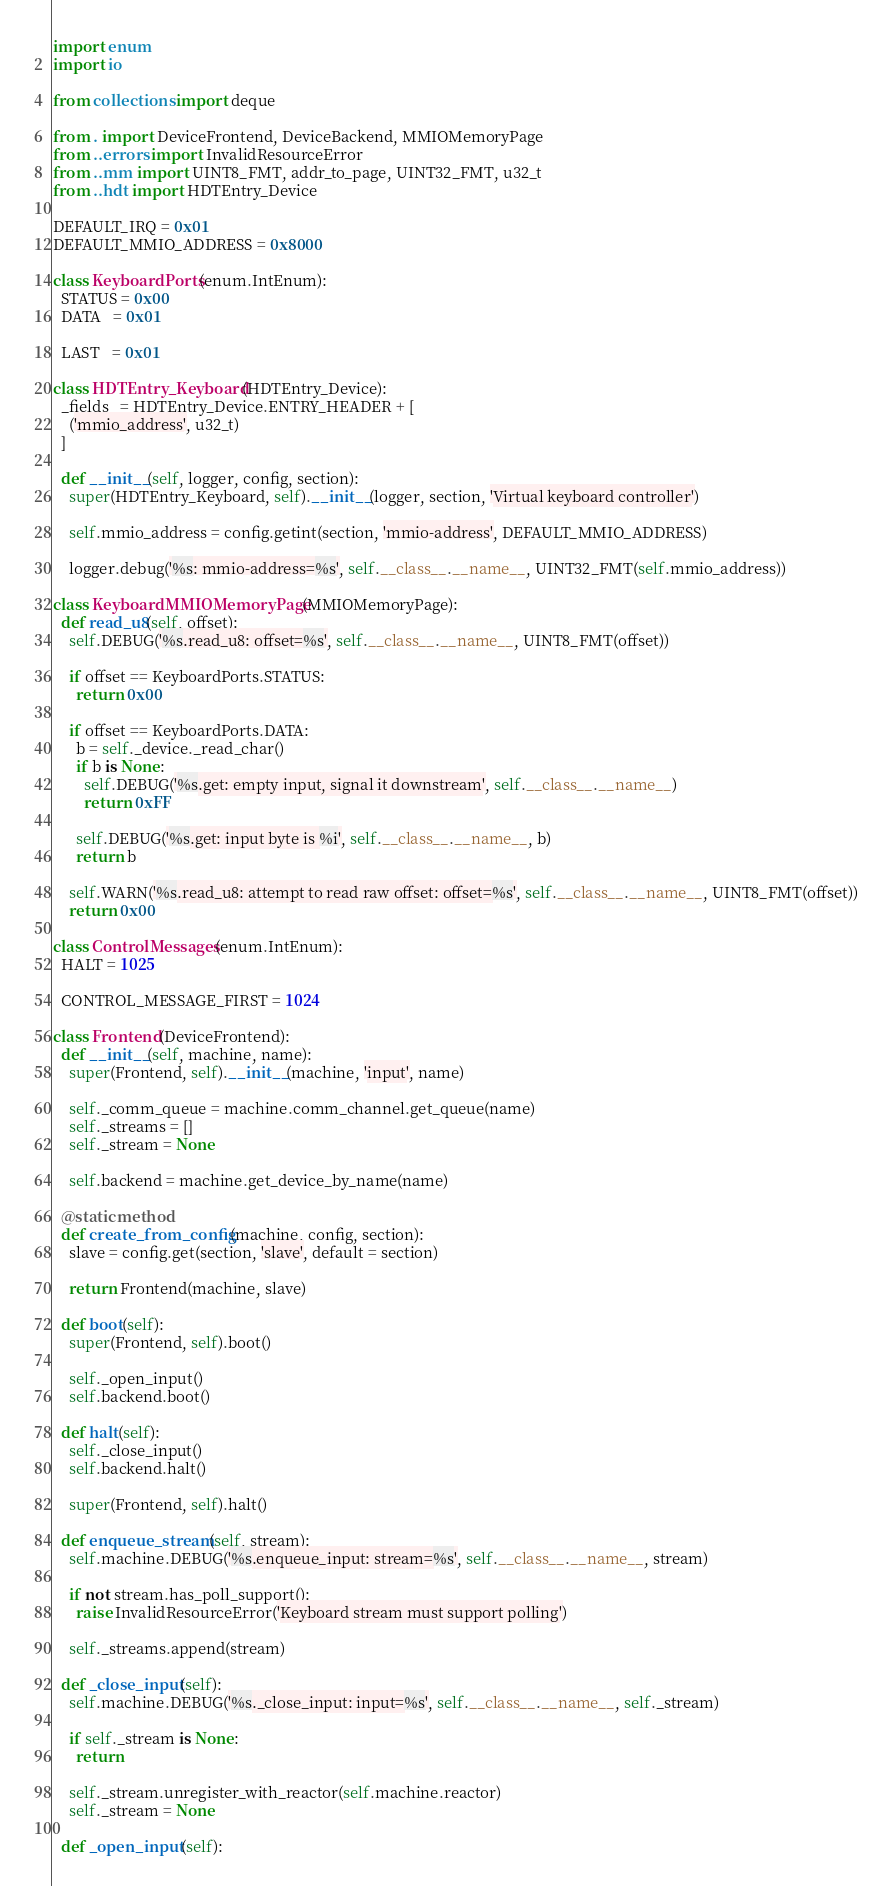<code> <loc_0><loc_0><loc_500><loc_500><_Python_>
import enum
import io

from collections import deque

from . import DeviceFrontend, DeviceBackend, MMIOMemoryPage
from ..errors import InvalidResourceError
from ..mm import UINT8_FMT, addr_to_page, UINT32_FMT, u32_t
from ..hdt import HDTEntry_Device

DEFAULT_IRQ = 0x01
DEFAULT_MMIO_ADDRESS = 0x8000

class KeyboardPorts(enum.IntEnum):
  STATUS = 0x00
  DATA   = 0x01

  LAST   = 0x01

class HDTEntry_Keyboard(HDTEntry_Device):
  _fields_ = HDTEntry_Device.ENTRY_HEADER + [
    ('mmio_address', u32_t)
  ]

  def __init__(self, logger, config, section):
    super(HDTEntry_Keyboard, self).__init__(logger, section, 'Virtual keyboard controller')

    self.mmio_address = config.getint(section, 'mmio-address', DEFAULT_MMIO_ADDRESS)

    logger.debug('%s: mmio-address=%s', self.__class__.__name__, UINT32_FMT(self.mmio_address))

class KeyboardMMIOMemoryPage(MMIOMemoryPage):
  def read_u8(self, offset):
    self.DEBUG('%s.read_u8: offset=%s', self.__class__.__name__, UINT8_FMT(offset))

    if offset == KeyboardPorts.STATUS:
      return 0x00

    if offset == KeyboardPorts.DATA:
      b = self._device._read_char()
      if b is None:
        self.DEBUG('%s.get: empty input, signal it downstream', self.__class__.__name__)
        return 0xFF

      self.DEBUG('%s.get: input byte is %i', self.__class__.__name__, b)
      return b

    self.WARN('%s.read_u8: attempt to read raw offset: offset=%s', self.__class__.__name__, UINT8_FMT(offset))
    return 0x00

class ControlMessages(enum.IntEnum):
  HALT = 1025

  CONTROL_MESSAGE_FIRST = 1024

class Frontend(DeviceFrontend):
  def __init__(self, machine, name):
    super(Frontend, self).__init__(machine, 'input', name)

    self._comm_queue = machine.comm_channel.get_queue(name)
    self._streams = []
    self._stream = None

    self.backend = machine.get_device_by_name(name)

  @staticmethod
  def create_from_config(machine, config, section):
    slave = config.get(section, 'slave', default = section)

    return Frontend(machine, slave)

  def boot(self):
    super(Frontend, self).boot()

    self._open_input()
    self.backend.boot()

  def halt(self):
    self._close_input()
    self.backend.halt()

    super(Frontend, self).halt()

  def enqueue_stream(self, stream):
    self.machine.DEBUG('%s.enqueue_input: stream=%s', self.__class__.__name__, stream)

    if not stream.has_poll_support():
      raise InvalidResourceError('Keyboard stream must support polling')

    self._streams.append(stream)

  def _close_input(self):
    self.machine.DEBUG('%s._close_input: input=%s', self.__class__.__name__, self._stream)

    if self._stream is None:
      return

    self._stream.unregister_with_reactor(self.machine.reactor)
    self._stream = None

  def _open_input(self):</code> 